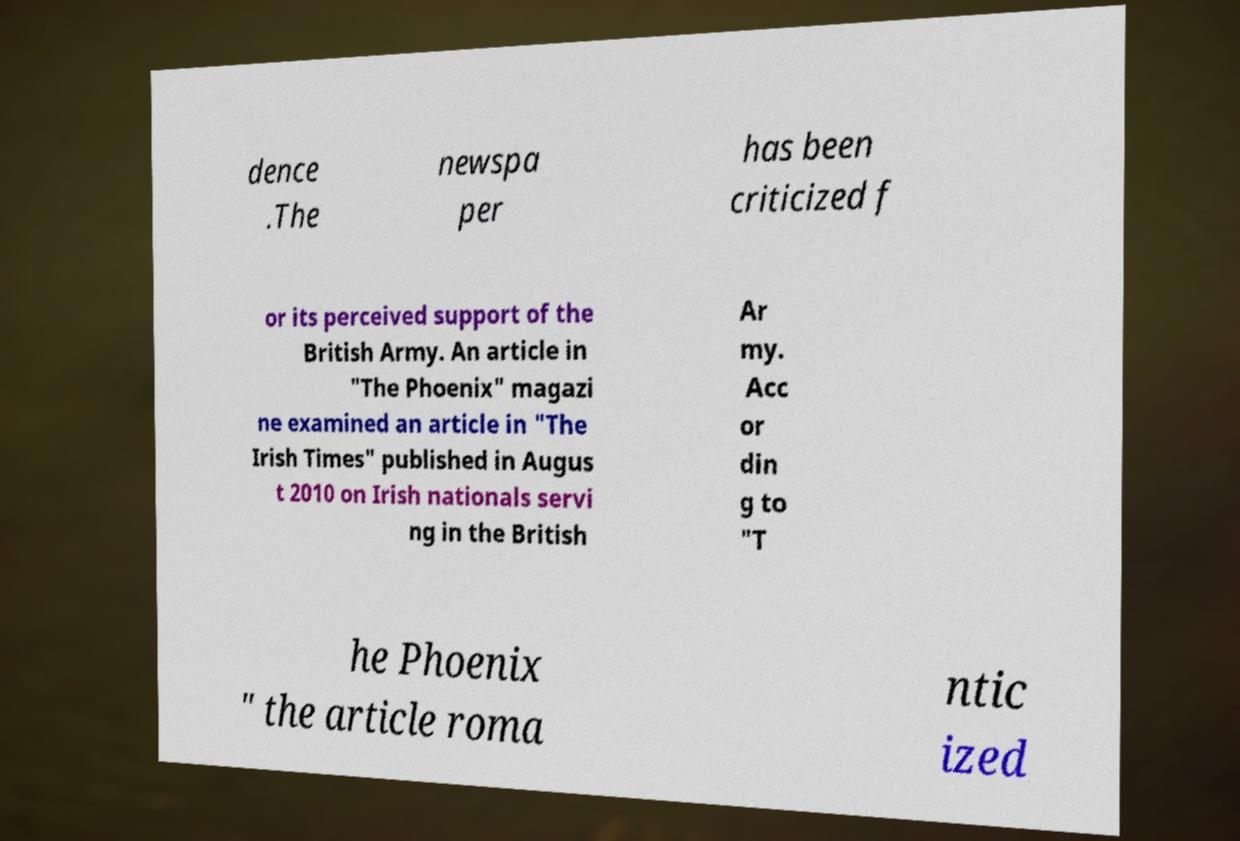For documentation purposes, I need the text within this image transcribed. Could you provide that? dence .The newspa per has been criticized f or its perceived support of the British Army. An article in "The Phoenix" magazi ne examined an article in "The Irish Times" published in Augus t 2010 on Irish nationals servi ng in the British Ar my. Acc or din g to "T he Phoenix " the article roma ntic ized 